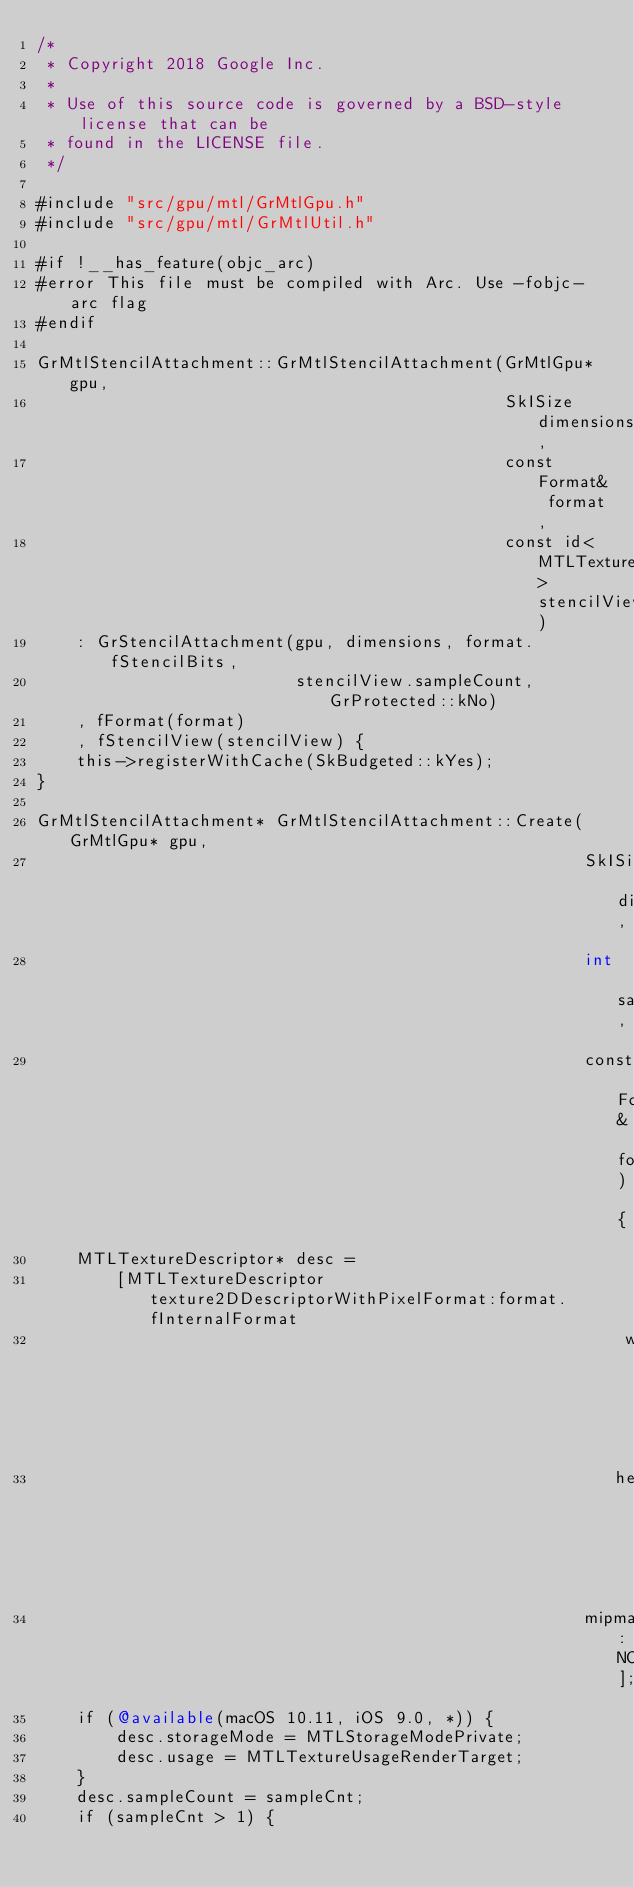Convert code to text. <code><loc_0><loc_0><loc_500><loc_500><_ObjectiveC_>/*
 * Copyright 2018 Google Inc.
 *
 * Use of this source code is governed by a BSD-style license that can be
 * found in the LICENSE file.
 */

#include "src/gpu/mtl/GrMtlGpu.h"
#include "src/gpu/mtl/GrMtlUtil.h"

#if !__has_feature(objc_arc)
#error This file must be compiled with Arc. Use -fobjc-arc flag
#endif

GrMtlStencilAttachment::GrMtlStencilAttachment(GrMtlGpu* gpu,
                                               SkISize dimensions,
                                               const Format& format,
                                               const id<MTLTexture> stencilView)
    : GrStencilAttachment(gpu, dimensions, format.fStencilBits,
                          stencilView.sampleCount, GrProtected::kNo)
    , fFormat(format)
    , fStencilView(stencilView) {
    this->registerWithCache(SkBudgeted::kYes);
}

GrMtlStencilAttachment* GrMtlStencilAttachment::Create(GrMtlGpu* gpu,
                                                       SkISize dimensions,
                                                       int sampleCnt,
                                                       const Format& format) {
    MTLTextureDescriptor* desc =
        [MTLTextureDescriptor texture2DDescriptorWithPixelFormat:format.fInternalFormat
                                                           width:dimensions.width()
                                                          height:dimensions.height()
                                                       mipmapped:NO];
    if (@available(macOS 10.11, iOS 9.0, *)) {
        desc.storageMode = MTLStorageModePrivate;
        desc.usage = MTLTextureUsageRenderTarget;
    }
    desc.sampleCount = sampleCnt;
    if (sampleCnt > 1) {</code> 